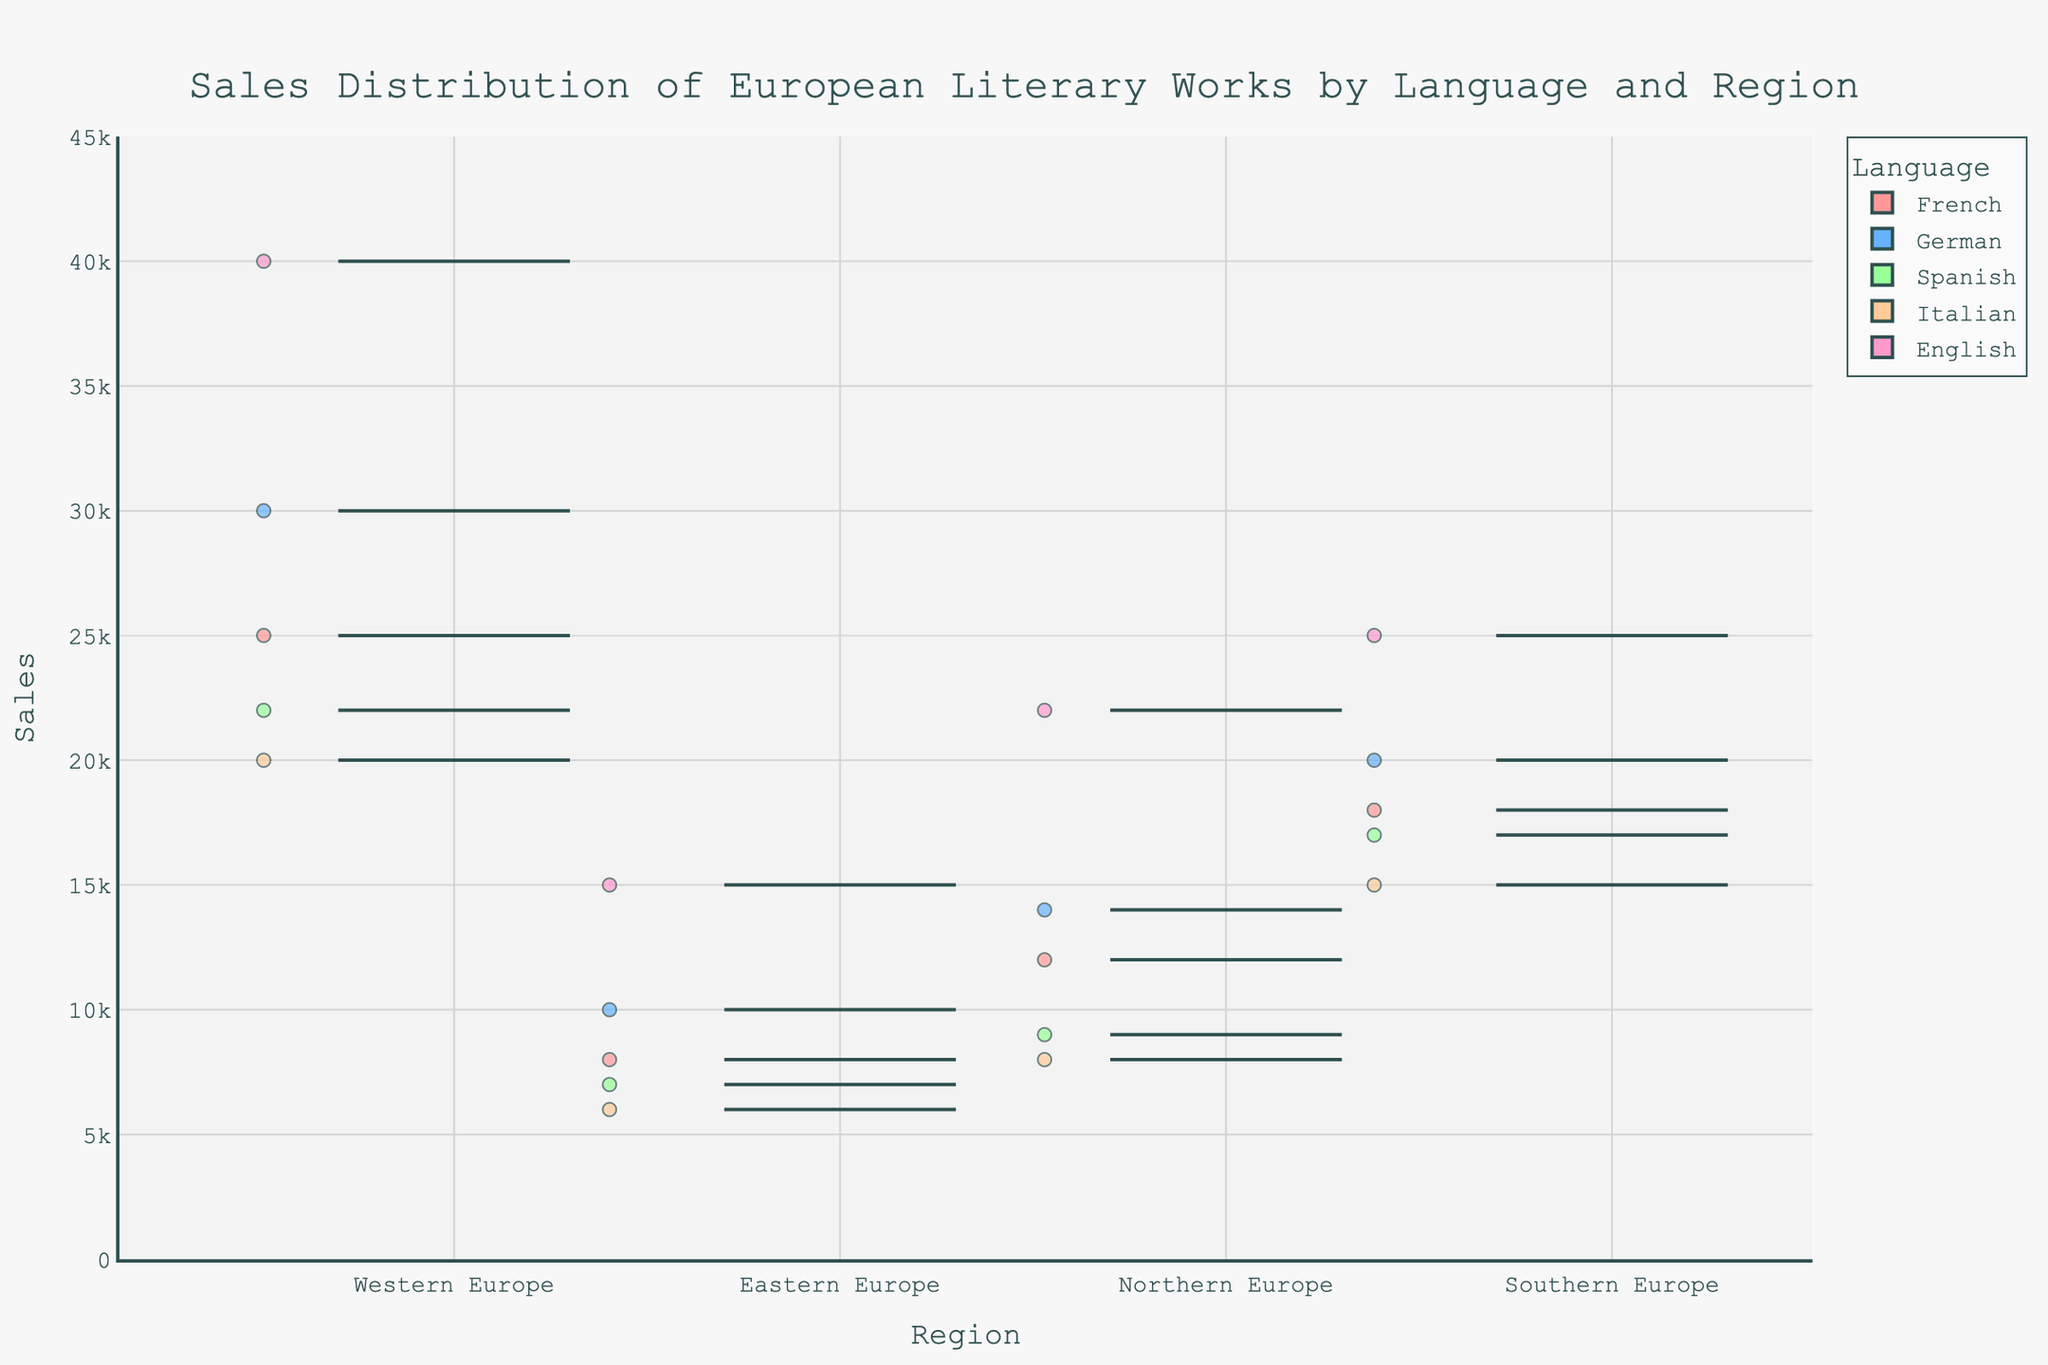What's the title of the figure? The title of the figure is prominently displayed at the top and typically provides a summary of what the plot represents. The title is "Sales Distribution of European Literary Works by Language and Region".
Answer: Sales Distribution of European Literary Works by Language and Region Which language in Western Europe has the highest sales? By observing the box plot for Western Europe and identifying the highest point, we see that English has the highest sales in Western Europe.
Answer: English How does the median sales of French works compare to the median sales of German works in Northern Europe? To compare median values, observe the middle line inside the boxes for French and German in Northern Europe. The median line for French is lower than that for German.
Answer: The median sales of French works is lower than German works Which region shows the most variability in sales for Spanish literary works? Variability can be determined by the range from the bottom whisker to the top whisker. For Spanish works, Eastern and Southern Europe show large whisker ranges, with Eastern Europe showing the largest.
Answer: Eastern Europe Are there any outliers in the sales distribution for Italian works in Northern Europe? Outliers are typically shown as individual points outside the whiskers of each box plot. For Italian works in Northern Europe, no individual points lie outside whiskers.
Answer: No What's the range in sales for English works in Western Europe? The range is the difference between the highest and lowest values. For English works in Western Europe, the highest point is 40000 and the lowest is around 22000, making the range 40000 - 22000 = 18000.
Answer: 18000 Which language and region combination has the smallest interquartile range (IQR) in sales? IQR is determined by the height of the box from Q1 to Q3. Analyze all boxes, and it appears that the Spanish works in Southern Europe have the smallest IQR.
Answer: Spanish in Southern Europe How do sales of French works in Western Europe compare with those in Southern Europe? Sales distributions can be compared by looking at the location and spread of the boxes. The sales of French works in Western Europe are higher on average and have more spread compared to Southern Europe.
Answer: Higher in Western Europe Which language in Eastern Europe has the lowest maximum sales? The maximum value is the top whisker point for each language. Among the languages in Eastern Europe, Italian has the lowest maximum sales.
Answer: Italian Explain the sales distribution for German works across all regions. For German works, the box plots show: highest median sales in Western Europe, followed by Southern, Northern, and Eastern Europe. The variability is highest in Western Europe, indicating more fluctuation with a wider range from minimum to maximum.
Answer: Highest median in Western Europe, most variability in Western Europe 